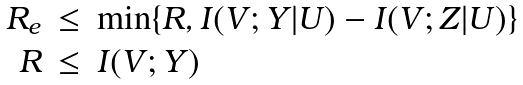Convert formula to latex. <formula><loc_0><loc_0><loc_500><loc_500>\begin{array} { r c l } R _ { e } & \leq & \min \{ R , I ( V ; Y | U ) - I ( V ; Z | U ) \} \\ R & \leq & I ( V ; Y ) \end{array}</formula> 